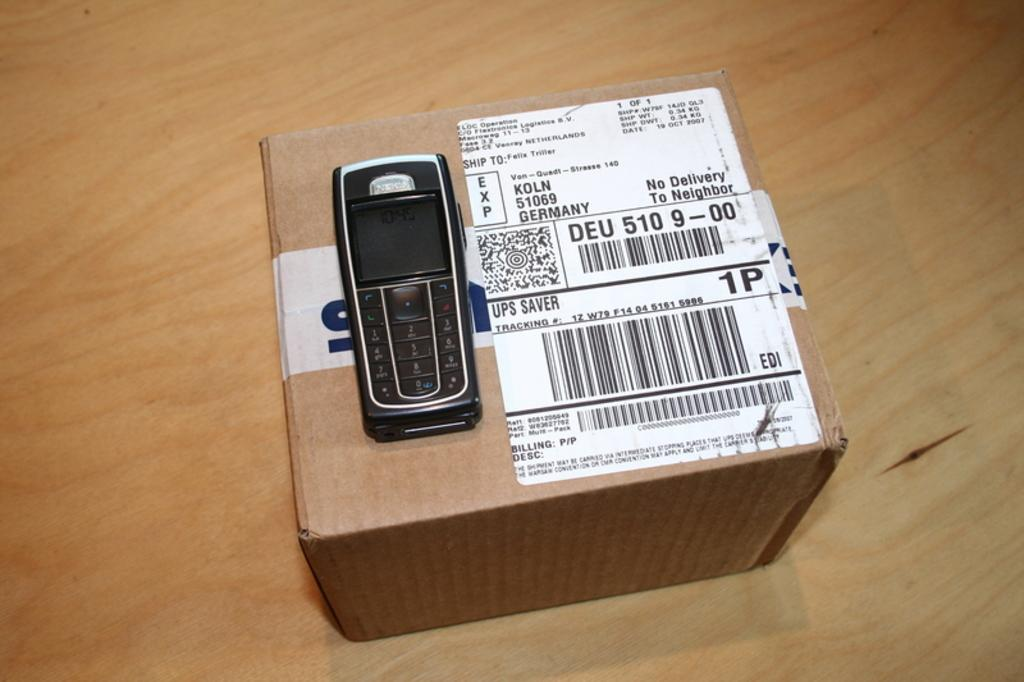<image>
Relay a brief, clear account of the picture shown. The package in the picture was delivered to Germany. 